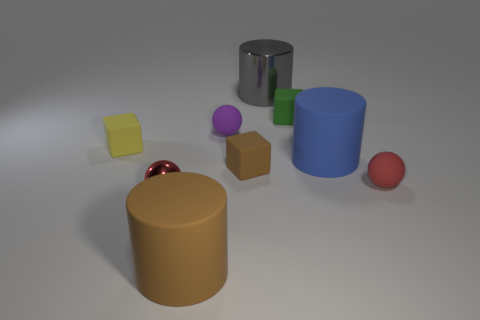Subtract all small rubber spheres. How many spheres are left? 1 Add 1 tiny green rubber objects. How many objects exist? 10 Subtract all cylinders. How many objects are left? 6 Subtract 0 yellow cylinders. How many objects are left? 9 Subtract all red balls. Subtract all red matte spheres. How many objects are left? 6 Add 5 yellow blocks. How many yellow blocks are left? 6 Add 4 brown objects. How many brown objects exist? 6 